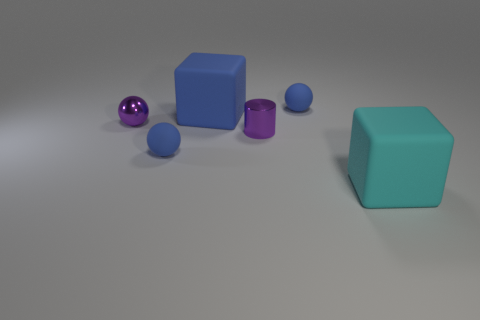Subtract all purple metallic balls. How many balls are left? 2 Subtract all gray cylinders. How many blue spheres are left? 2 Subtract all purple spheres. How many spheres are left? 2 Add 2 large purple cubes. How many objects exist? 8 Subtract all cylinders. How many objects are left? 5 Add 1 big cubes. How many big cubes exist? 3 Subtract 0 cyan cylinders. How many objects are left? 6 Subtract all cyan spheres. Subtract all blue blocks. How many spheres are left? 3 Subtract all cyan matte blocks. Subtract all yellow things. How many objects are left? 5 Add 1 cyan matte cubes. How many cyan matte cubes are left? 2 